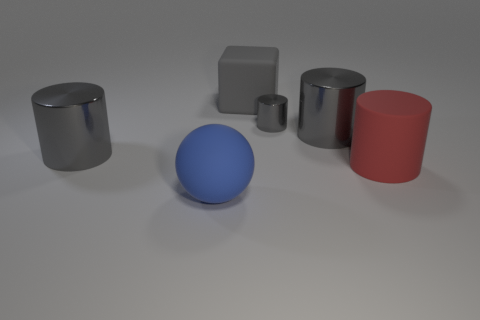What number of red cylinders are to the right of the big rubber object that is in front of the big red rubber cylinder that is on the right side of the big blue rubber sphere? 1 